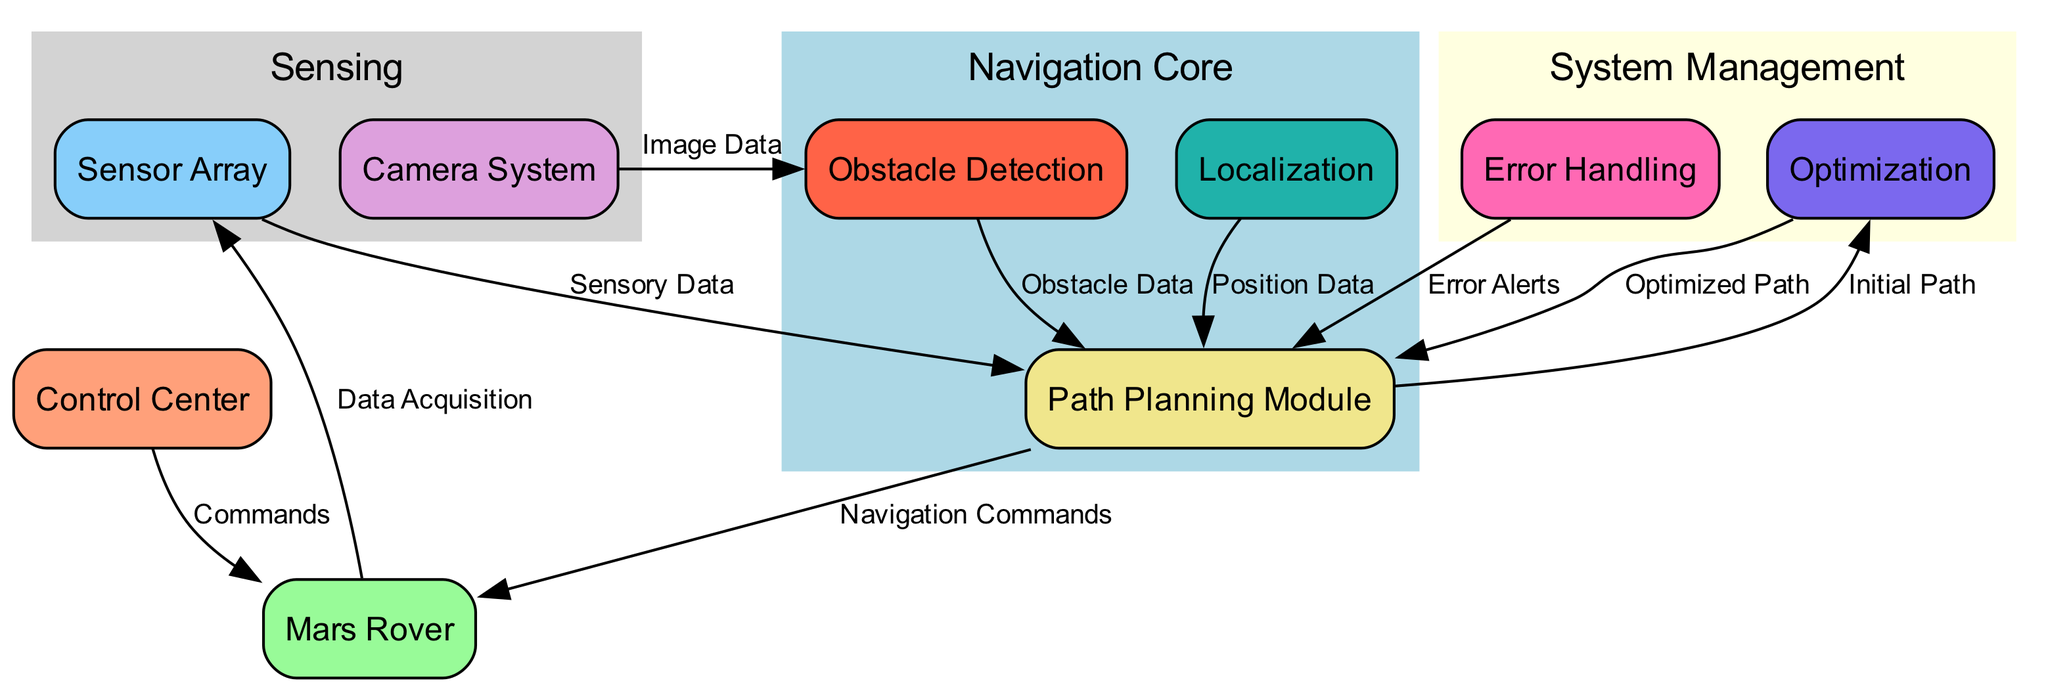What is the total number of nodes in the diagram? The diagram lists the following nodes: Control Center, Mars Rover, Sensor Array, Camera System, Path Planning Module, Obstacle Detection, Localization, Error Handling, and Optimization. Counting these gives us a total of nine nodes.
Answer: Nine Which node receives commands from the Control Center? According to the edge labeled "Commands," the Mars Rover receives commands from the Control Center.
Answer: Mars Rover How many edges connect the Path Planning Module to other nodes? By examining the diagram, the Path Planning Module has outgoing edges to Optimization, Mars Rover, Error Handling, Obstacle Detection, and Localization, indicating that it connects to five other nodes through these edges.
Answer: Five What type of data does the Camera System provide to Obstacle Detection? The edge labeled "Image Data" shows that the Camera System provides image data to the Obstacle Detection module.
Answer: Image Data Which module processes Error Alerts to affect path planning? The Edge labeled "Error Alerts" from Error Handling shows that this module affects the Path Planning Module by providing alerts regarding errors.
Answer: Path Planning Module What is the relationship between the Optimization and Path Planning Module? The diagram shows a two-way edge where the Optimization module provides an Optimized Path to the Path Planning Module, and in return, it receives an Initial Path from it.
Answer: Optimization In which cluster is the Localization node located? The Localization node resides in the "Navigation Core" cluster, as defined in the subgraph section of the diagram that includes the Path Planning Module, Obstacle Detection, and Localization.
Answer: Navigation Core What is the primary function of the Sensor Array in the diagram? The Sensor Array's function is clarified by the edge labeled "Sensory Data," which indicates it is responsible for data acquisition to feed into the Path Planning Module.
Answer: Data Acquisition How does the Error Handling module interact with the Path Planning Module? The Error Handling module provides Error Alerts to the Path Planning Module, which implies its role in monitoring and correcting navigation strategies based on errors detected.
Answer: Error Alerts 